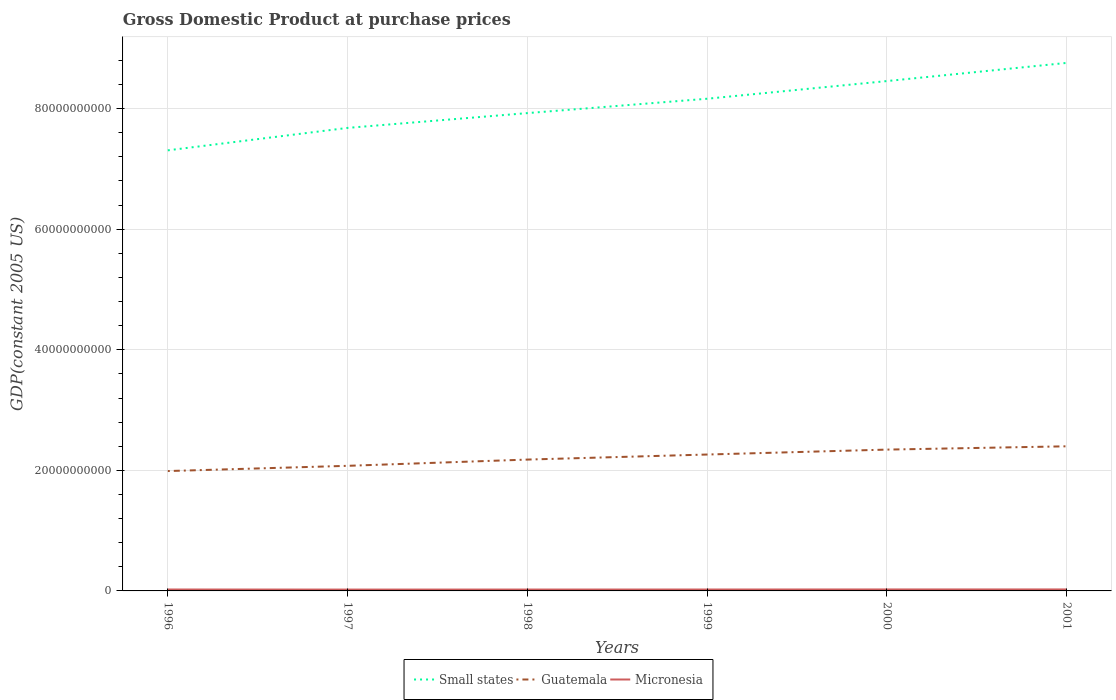Is the number of lines equal to the number of legend labels?
Give a very brief answer. Yes. Across all years, what is the maximum GDP at purchase prices in Small states?
Ensure brevity in your answer.  7.31e+1. In which year was the GDP at purchase prices in Micronesia maximum?
Ensure brevity in your answer.  1997. What is the total GDP at purchase prices in Micronesia in the graph?
Provide a short and direct response. -2.46e+07. What is the difference between the highest and the second highest GDP at purchase prices in Micronesia?
Make the answer very short. 2.46e+07. How many lines are there?
Your answer should be very brief. 3. Are the values on the major ticks of Y-axis written in scientific E-notation?
Make the answer very short. No. Where does the legend appear in the graph?
Ensure brevity in your answer.  Bottom center. What is the title of the graph?
Your answer should be compact. Gross Domestic Product at purchase prices. What is the label or title of the X-axis?
Ensure brevity in your answer.  Years. What is the label or title of the Y-axis?
Give a very brief answer. GDP(constant 2005 US). What is the GDP(constant 2005 US) in Small states in 1996?
Your response must be concise. 7.31e+1. What is the GDP(constant 2005 US) in Guatemala in 1996?
Your answer should be compact. 1.99e+1. What is the GDP(constant 2005 US) of Micronesia in 1996?
Ensure brevity in your answer.  2.37e+08. What is the GDP(constant 2005 US) of Small states in 1997?
Make the answer very short. 7.68e+1. What is the GDP(constant 2005 US) in Guatemala in 1997?
Ensure brevity in your answer.  2.08e+1. What is the GDP(constant 2005 US) of Micronesia in 1997?
Ensure brevity in your answer.  2.22e+08. What is the GDP(constant 2005 US) of Small states in 1998?
Your response must be concise. 7.93e+1. What is the GDP(constant 2005 US) in Guatemala in 1998?
Provide a succinct answer. 2.18e+1. What is the GDP(constant 2005 US) in Micronesia in 1998?
Ensure brevity in your answer.  2.29e+08. What is the GDP(constant 2005 US) of Small states in 1999?
Your response must be concise. 8.16e+1. What is the GDP(constant 2005 US) of Guatemala in 1999?
Give a very brief answer. 2.26e+1. What is the GDP(constant 2005 US) of Micronesia in 1999?
Provide a short and direct response. 2.32e+08. What is the GDP(constant 2005 US) in Small states in 2000?
Your answer should be very brief. 8.46e+1. What is the GDP(constant 2005 US) of Guatemala in 2000?
Provide a short and direct response. 2.34e+1. What is the GDP(constant 2005 US) in Micronesia in 2000?
Provide a succinct answer. 2.42e+08. What is the GDP(constant 2005 US) of Small states in 2001?
Give a very brief answer. 8.76e+1. What is the GDP(constant 2005 US) of Guatemala in 2001?
Provide a succinct answer. 2.40e+1. What is the GDP(constant 2005 US) of Micronesia in 2001?
Offer a terse response. 2.47e+08. Across all years, what is the maximum GDP(constant 2005 US) in Small states?
Provide a short and direct response. 8.76e+1. Across all years, what is the maximum GDP(constant 2005 US) in Guatemala?
Give a very brief answer. 2.40e+1. Across all years, what is the maximum GDP(constant 2005 US) in Micronesia?
Your answer should be very brief. 2.47e+08. Across all years, what is the minimum GDP(constant 2005 US) in Small states?
Provide a short and direct response. 7.31e+1. Across all years, what is the minimum GDP(constant 2005 US) in Guatemala?
Provide a short and direct response. 1.99e+1. Across all years, what is the minimum GDP(constant 2005 US) of Micronesia?
Offer a terse response. 2.22e+08. What is the total GDP(constant 2005 US) in Small states in the graph?
Give a very brief answer. 4.83e+11. What is the total GDP(constant 2005 US) in Guatemala in the graph?
Offer a very short reply. 1.32e+11. What is the total GDP(constant 2005 US) in Micronesia in the graph?
Provide a succinct answer. 1.41e+09. What is the difference between the GDP(constant 2005 US) of Small states in 1996 and that in 1997?
Keep it short and to the point. -3.72e+09. What is the difference between the GDP(constant 2005 US) in Guatemala in 1996 and that in 1997?
Offer a terse response. -8.68e+08. What is the difference between the GDP(constant 2005 US) in Micronesia in 1996 and that in 1997?
Your answer should be compact. 1.43e+07. What is the difference between the GDP(constant 2005 US) of Small states in 1996 and that in 1998?
Your answer should be compact. -6.17e+09. What is the difference between the GDP(constant 2005 US) in Guatemala in 1996 and that in 1998?
Your response must be concise. -1.90e+09. What is the difference between the GDP(constant 2005 US) of Micronesia in 1996 and that in 1998?
Keep it short and to the point. 7.78e+06. What is the difference between the GDP(constant 2005 US) in Small states in 1996 and that in 1999?
Offer a very short reply. -8.56e+09. What is the difference between the GDP(constant 2005 US) in Guatemala in 1996 and that in 1999?
Make the answer very short. -2.74e+09. What is the difference between the GDP(constant 2005 US) in Micronesia in 1996 and that in 1999?
Provide a succinct answer. 4.61e+06. What is the difference between the GDP(constant 2005 US) in Small states in 1996 and that in 2000?
Ensure brevity in your answer.  -1.15e+1. What is the difference between the GDP(constant 2005 US) in Guatemala in 1996 and that in 2000?
Give a very brief answer. -3.56e+09. What is the difference between the GDP(constant 2005 US) of Micronesia in 1996 and that in 2000?
Provide a succinct answer. -5.97e+06. What is the difference between the GDP(constant 2005 US) in Small states in 1996 and that in 2001?
Offer a terse response. -1.45e+1. What is the difference between the GDP(constant 2005 US) in Guatemala in 1996 and that in 2001?
Your response must be concise. -4.11e+09. What is the difference between the GDP(constant 2005 US) in Micronesia in 1996 and that in 2001?
Offer a terse response. -1.02e+07. What is the difference between the GDP(constant 2005 US) in Small states in 1997 and that in 1998?
Your response must be concise. -2.45e+09. What is the difference between the GDP(constant 2005 US) in Guatemala in 1997 and that in 1998?
Your response must be concise. -1.04e+09. What is the difference between the GDP(constant 2005 US) of Micronesia in 1997 and that in 1998?
Offer a terse response. -6.57e+06. What is the difference between the GDP(constant 2005 US) of Small states in 1997 and that in 1999?
Your response must be concise. -4.84e+09. What is the difference between the GDP(constant 2005 US) of Guatemala in 1997 and that in 1999?
Provide a short and direct response. -1.87e+09. What is the difference between the GDP(constant 2005 US) in Micronesia in 1997 and that in 1999?
Provide a succinct answer. -9.73e+06. What is the difference between the GDP(constant 2005 US) in Small states in 1997 and that in 2000?
Keep it short and to the point. -7.77e+09. What is the difference between the GDP(constant 2005 US) in Guatemala in 1997 and that in 2000?
Offer a terse response. -2.69e+09. What is the difference between the GDP(constant 2005 US) of Micronesia in 1997 and that in 2000?
Keep it short and to the point. -2.03e+07. What is the difference between the GDP(constant 2005 US) of Small states in 1997 and that in 2001?
Keep it short and to the point. -1.08e+1. What is the difference between the GDP(constant 2005 US) of Guatemala in 1997 and that in 2001?
Your answer should be very brief. -3.24e+09. What is the difference between the GDP(constant 2005 US) in Micronesia in 1997 and that in 2001?
Your answer should be very brief. -2.46e+07. What is the difference between the GDP(constant 2005 US) in Small states in 1998 and that in 1999?
Your answer should be very brief. -2.38e+09. What is the difference between the GDP(constant 2005 US) of Guatemala in 1998 and that in 1999?
Give a very brief answer. -8.38e+08. What is the difference between the GDP(constant 2005 US) of Micronesia in 1998 and that in 1999?
Make the answer very short. -3.17e+06. What is the difference between the GDP(constant 2005 US) in Small states in 1998 and that in 2000?
Provide a short and direct response. -5.32e+09. What is the difference between the GDP(constant 2005 US) in Guatemala in 1998 and that in 2000?
Offer a terse response. -1.65e+09. What is the difference between the GDP(constant 2005 US) in Micronesia in 1998 and that in 2000?
Provide a succinct answer. -1.37e+07. What is the difference between the GDP(constant 2005 US) of Small states in 1998 and that in 2001?
Offer a terse response. -8.33e+09. What is the difference between the GDP(constant 2005 US) of Guatemala in 1998 and that in 2001?
Your answer should be compact. -2.20e+09. What is the difference between the GDP(constant 2005 US) of Micronesia in 1998 and that in 2001?
Your response must be concise. -1.80e+07. What is the difference between the GDP(constant 2005 US) in Small states in 1999 and that in 2000?
Keep it short and to the point. -2.93e+09. What is the difference between the GDP(constant 2005 US) of Guatemala in 1999 and that in 2000?
Offer a very short reply. -8.17e+08. What is the difference between the GDP(constant 2005 US) in Micronesia in 1999 and that in 2000?
Offer a very short reply. -1.06e+07. What is the difference between the GDP(constant 2005 US) in Small states in 1999 and that in 2001?
Your response must be concise. -5.94e+09. What is the difference between the GDP(constant 2005 US) in Guatemala in 1999 and that in 2001?
Offer a terse response. -1.36e+09. What is the difference between the GDP(constant 2005 US) in Micronesia in 1999 and that in 2001?
Give a very brief answer. -1.48e+07. What is the difference between the GDP(constant 2005 US) in Small states in 2000 and that in 2001?
Keep it short and to the point. -3.01e+09. What is the difference between the GDP(constant 2005 US) of Guatemala in 2000 and that in 2001?
Provide a succinct answer. -5.47e+08. What is the difference between the GDP(constant 2005 US) of Micronesia in 2000 and that in 2001?
Keep it short and to the point. -4.24e+06. What is the difference between the GDP(constant 2005 US) of Small states in 1996 and the GDP(constant 2005 US) of Guatemala in 1997?
Make the answer very short. 5.23e+1. What is the difference between the GDP(constant 2005 US) in Small states in 1996 and the GDP(constant 2005 US) in Micronesia in 1997?
Make the answer very short. 7.29e+1. What is the difference between the GDP(constant 2005 US) of Guatemala in 1996 and the GDP(constant 2005 US) of Micronesia in 1997?
Offer a terse response. 1.97e+1. What is the difference between the GDP(constant 2005 US) in Small states in 1996 and the GDP(constant 2005 US) in Guatemala in 1998?
Ensure brevity in your answer.  5.13e+1. What is the difference between the GDP(constant 2005 US) in Small states in 1996 and the GDP(constant 2005 US) in Micronesia in 1998?
Offer a terse response. 7.29e+1. What is the difference between the GDP(constant 2005 US) in Guatemala in 1996 and the GDP(constant 2005 US) in Micronesia in 1998?
Offer a terse response. 1.97e+1. What is the difference between the GDP(constant 2005 US) of Small states in 1996 and the GDP(constant 2005 US) of Guatemala in 1999?
Keep it short and to the point. 5.05e+1. What is the difference between the GDP(constant 2005 US) of Small states in 1996 and the GDP(constant 2005 US) of Micronesia in 1999?
Your response must be concise. 7.29e+1. What is the difference between the GDP(constant 2005 US) of Guatemala in 1996 and the GDP(constant 2005 US) of Micronesia in 1999?
Keep it short and to the point. 1.97e+1. What is the difference between the GDP(constant 2005 US) of Small states in 1996 and the GDP(constant 2005 US) of Guatemala in 2000?
Give a very brief answer. 4.96e+1. What is the difference between the GDP(constant 2005 US) in Small states in 1996 and the GDP(constant 2005 US) in Micronesia in 2000?
Offer a very short reply. 7.28e+1. What is the difference between the GDP(constant 2005 US) of Guatemala in 1996 and the GDP(constant 2005 US) of Micronesia in 2000?
Your answer should be very brief. 1.96e+1. What is the difference between the GDP(constant 2005 US) of Small states in 1996 and the GDP(constant 2005 US) of Guatemala in 2001?
Provide a succinct answer. 4.91e+1. What is the difference between the GDP(constant 2005 US) of Small states in 1996 and the GDP(constant 2005 US) of Micronesia in 2001?
Your response must be concise. 7.28e+1. What is the difference between the GDP(constant 2005 US) in Guatemala in 1996 and the GDP(constant 2005 US) in Micronesia in 2001?
Offer a terse response. 1.96e+1. What is the difference between the GDP(constant 2005 US) of Small states in 1997 and the GDP(constant 2005 US) of Guatemala in 1998?
Offer a terse response. 5.50e+1. What is the difference between the GDP(constant 2005 US) of Small states in 1997 and the GDP(constant 2005 US) of Micronesia in 1998?
Provide a short and direct response. 7.66e+1. What is the difference between the GDP(constant 2005 US) in Guatemala in 1997 and the GDP(constant 2005 US) in Micronesia in 1998?
Offer a terse response. 2.05e+1. What is the difference between the GDP(constant 2005 US) of Small states in 1997 and the GDP(constant 2005 US) of Guatemala in 1999?
Your answer should be compact. 5.42e+1. What is the difference between the GDP(constant 2005 US) in Small states in 1997 and the GDP(constant 2005 US) in Micronesia in 1999?
Your response must be concise. 7.66e+1. What is the difference between the GDP(constant 2005 US) of Guatemala in 1997 and the GDP(constant 2005 US) of Micronesia in 1999?
Your answer should be compact. 2.05e+1. What is the difference between the GDP(constant 2005 US) of Small states in 1997 and the GDP(constant 2005 US) of Guatemala in 2000?
Provide a succinct answer. 5.34e+1. What is the difference between the GDP(constant 2005 US) in Small states in 1997 and the GDP(constant 2005 US) in Micronesia in 2000?
Provide a short and direct response. 7.66e+1. What is the difference between the GDP(constant 2005 US) in Guatemala in 1997 and the GDP(constant 2005 US) in Micronesia in 2000?
Your response must be concise. 2.05e+1. What is the difference between the GDP(constant 2005 US) of Small states in 1997 and the GDP(constant 2005 US) of Guatemala in 2001?
Ensure brevity in your answer.  5.28e+1. What is the difference between the GDP(constant 2005 US) in Small states in 1997 and the GDP(constant 2005 US) in Micronesia in 2001?
Provide a short and direct response. 7.66e+1. What is the difference between the GDP(constant 2005 US) in Guatemala in 1997 and the GDP(constant 2005 US) in Micronesia in 2001?
Your response must be concise. 2.05e+1. What is the difference between the GDP(constant 2005 US) in Small states in 1998 and the GDP(constant 2005 US) in Guatemala in 1999?
Offer a terse response. 5.66e+1. What is the difference between the GDP(constant 2005 US) in Small states in 1998 and the GDP(constant 2005 US) in Micronesia in 1999?
Ensure brevity in your answer.  7.90e+1. What is the difference between the GDP(constant 2005 US) of Guatemala in 1998 and the GDP(constant 2005 US) of Micronesia in 1999?
Offer a very short reply. 2.16e+1. What is the difference between the GDP(constant 2005 US) of Small states in 1998 and the GDP(constant 2005 US) of Guatemala in 2000?
Your response must be concise. 5.58e+1. What is the difference between the GDP(constant 2005 US) of Small states in 1998 and the GDP(constant 2005 US) of Micronesia in 2000?
Provide a succinct answer. 7.90e+1. What is the difference between the GDP(constant 2005 US) of Guatemala in 1998 and the GDP(constant 2005 US) of Micronesia in 2000?
Make the answer very short. 2.15e+1. What is the difference between the GDP(constant 2005 US) of Small states in 1998 and the GDP(constant 2005 US) of Guatemala in 2001?
Your answer should be compact. 5.53e+1. What is the difference between the GDP(constant 2005 US) in Small states in 1998 and the GDP(constant 2005 US) in Micronesia in 2001?
Provide a succinct answer. 7.90e+1. What is the difference between the GDP(constant 2005 US) in Guatemala in 1998 and the GDP(constant 2005 US) in Micronesia in 2001?
Keep it short and to the point. 2.15e+1. What is the difference between the GDP(constant 2005 US) in Small states in 1999 and the GDP(constant 2005 US) in Guatemala in 2000?
Ensure brevity in your answer.  5.82e+1. What is the difference between the GDP(constant 2005 US) in Small states in 1999 and the GDP(constant 2005 US) in Micronesia in 2000?
Your answer should be compact. 8.14e+1. What is the difference between the GDP(constant 2005 US) of Guatemala in 1999 and the GDP(constant 2005 US) of Micronesia in 2000?
Ensure brevity in your answer.  2.24e+1. What is the difference between the GDP(constant 2005 US) of Small states in 1999 and the GDP(constant 2005 US) of Guatemala in 2001?
Offer a terse response. 5.77e+1. What is the difference between the GDP(constant 2005 US) in Small states in 1999 and the GDP(constant 2005 US) in Micronesia in 2001?
Your response must be concise. 8.14e+1. What is the difference between the GDP(constant 2005 US) of Guatemala in 1999 and the GDP(constant 2005 US) of Micronesia in 2001?
Your response must be concise. 2.24e+1. What is the difference between the GDP(constant 2005 US) in Small states in 2000 and the GDP(constant 2005 US) in Guatemala in 2001?
Provide a succinct answer. 6.06e+1. What is the difference between the GDP(constant 2005 US) in Small states in 2000 and the GDP(constant 2005 US) in Micronesia in 2001?
Provide a succinct answer. 8.43e+1. What is the difference between the GDP(constant 2005 US) in Guatemala in 2000 and the GDP(constant 2005 US) in Micronesia in 2001?
Make the answer very short. 2.32e+1. What is the average GDP(constant 2005 US) of Small states per year?
Your answer should be compact. 8.05e+1. What is the average GDP(constant 2005 US) in Guatemala per year?
Offer a very short reply. 2.21e+1. What is the average GDP(constant 2005 US) of Micronesia per year?
Provide a short and direct response. 2.35e+08. In the year 1996, what is the difference between the GDP(constant 2005 US) in Small states and GDP(constant 2005 US) in Guatemala?
Your response must be concise. 5.32e+1. In the year 1996, what is the difference between the GDP(constant 2005 US) of Small states and GDP(constant 2005 US) of Micronesia?
Keep it short and to the point. 7.28e+1. In the year 1996, what is the difference between the GDP(constant 2005 US) in Guatemala and GDP(constant 2005 US) in Micronesia?
Keep it short and to the point. 1.96e+1. In the year 1997, what is the difference between the GDP(constant 2005 US) of Small states and GDP(constant 2005 US) of Guatemala?
Make the answer very short. 5.61e+1. In the year 1997, what is the difference between the GDP(constant 2005 US) in Small states and GDP(constant 2005 US) in Micronesia?
Your response must be concise. 7.66e+1. In the year 1997, what is the difference between the GDP(constant 2005 US) of Guatemala and GDP(constant 2005 US) of Micronesia?
Provide a succinct answer. 2.05e+1. In the year 1998, what is the difference between the GDP(constant 2005 US) of Small states and GDP(constant 2005 US) of Guatemala?
Ensure brevity in your answer.  5.75e+1. In the year 1998, what is the difference between the GDP(constant 2005 US) in Small states and GDP(constant 2005 US) in Micronesia?
Provide a short and direct response. 7.90e+1. In the year 1998, what is the difference between the GDP(constant 2005 US) in Guatemala and GDP(constant 2005 US) in Micronesia?
Offer a terse response. 2.16e+1. In the year 1999, what is the difference between the GDP(constant 2005 US) in Small states and GDP(constant 2005 US) in Guatemala?
Offer a very short reply. 5.90e+1. In the year 1999, what is the difference between the GDP(constant 2005 US) of Small states and GDP(constant 2005 US) of Micronesia?
Offer a very short reply. 8.14e+1. In the year 1999, what is the difference between the GDP(constant 2005 US) of Guatemala and GDP(constant 2005 US) of Micronesia?
Your answer should be compact. 2.24e+1. In the year 2000, what is the difference between the GDP(constant 2005 US) of Small states and GDP(constant 2005 US) of Guatemala?
Your answer should be compact. 6.11e+1. In the year 2000, what is the difference between the GDP(constant 2005 US) of Small states and GDP(constant 2005 US) of Micronesia?
Provide a succinct answer. 8.43e+1. In the year 2000, what is the difference between the GDP(constant 2005 US) in Guatemala and GDP(constant 2005 US) in Micronesia?
Provide a succinct answer. 2.32e+1. In the year 2001, what is the difference between the GDP(constant 2005 US) of Small states and GDP(constant 2005 US) of Guatemala?
Provide a short and direct response. 6.36e+1. In the year 2001, what is the difference between the GDP(constant 2005 US) in Small states and GDP(constant 2005 US) in Micronesia?
Offer a very short reply. 8.73e+1. In the year 2001, what is the difference between the GDP(constant 2005 US) of Guatemala and GDP(constant 2005 US) of Micronesia?
Keep it short and to the point. 2.37e+1. What is the ratio of the GDP(constant 2005 US) of Small states in 1996 to that in 1997?
Your response must be concise. 0.95. What is the ratio of the GDP(constant 2005 US) of Guatemala in 1996 to that in 1997?
Provide a short and direct response. 0.96. What is the ratio of the GDP(constant 2005 US) in Micronesia in 1996 to that in 1997?
Provide a succinct answer. 1.06. What is the ratio of the GDP(constant 2005 US) of Small states in 1996 to that in 1998?
Your answer should be very brief. 0.92. What is the ratio of the GDP(constant 2005 US) of Guatemala in 1996 to that in 1998?
Give a very brief answer. 0.91. What is the ratio of the GDP(constant 2005 US) of Micronesia in 1996 to that in 1998?
Offer a very short reply. 1.03. What is the ratio of the GDP(constant 2005 US) in Small states in 1996 to that in 1999?
Ensure brevity in your answer.  0.9. What is the ratio of the GDP(constant 2005 US) in Guatemala in 1996 to that in 1999?
Your answer should be very brief. 0.88. What is the ratio of the GDP(constant 2005 US) of Micronesia in 1996 to that in 1999?
Ensure brevity in your answer.  1.02. What is the ratio of the GDP(constant 2005 US) in Small states in 1996 to that in 2000?
Offer a terse response. 0.86. What is the ratio of the GDP(constant 2005 US) in Guatemala in 1996 to that in 2000?
Your response must be concise. 0.85. What is the ratio of the GDP(constant 2005 US) in Micronesia in 1996 to that in 2000?
Offer a very short reply. 0.98. What is the ratio of the GDP(constant 2005 US) of Small states in 1996 to that in 2001?
Provide a short and direct response. 0.83. What is the ratio of the GDP(constant 2005 US) of Guatemala in 1996 to that in 2001?
Keep it short and to the point. 0.83. What is the ratio of the GDP(constant 2005 US) of Micronesia in 1996 to that in 2001?
Offer a very short reply. 0.96. What is the ratio of the GDP(constant 2005 US) in Small states in 1997 to that in 1998?
Offer a very short reply. 0.97. What is the ratio of the GDP(constant 2005 US) in Guatemala in 1997 to that in 1998?
Ensure brevity in your answer.  0.95. What is the ratio of the GDP(constant 2005 US) in Micronesia in 1997 to that in 1998?
Keep it short and to the point. 0.97. What is the ratio of the GDP(constant 2005 US) in Small states in 1997 to that in 1999?
Your answer should be very brief. 0.94. What is the ratio of the GDP(constant 2005 US) in Guatemala in 1997 to that in 1999?
Your response must be concise. 0.92. What is the ratio of the GDP(constant 2005 US) of Micronesia in 1997 to that in 1999?
Your answer should be very brief. 0.96. What is the ratio of the GDP(constant 2005 US) of Small states in 1997 to that in 2000?
Your answer should be very brief. 0.91. What is the ratio of the GDP(constant 2005 US) in Guatemala in 1997 to that in 2000?
Your answer should be very brief. 0.89. What is the ratio of the GDP(constant 2005 US) of Micronesia in 1997 to that in 2000?
Your answer should be compact. 0.92. What is the ratio of the GDP(constant 2005 US) of Small states in 1997 to that in 2001?
Offer a terse response. 0.88. What is the ratio of the GDP(constant 2005 US) of Guatemala in 1997 to that in 2001?
Offer a very short reply. 0.86. What is the ratio of the GDP(constant 2005 US) in Micronesia in 1997 to that in 2001?
Give a very brief answer. 0.9. What is the ratio of the GDP(constant 2005 US) in Small states in 1998 to that in 1999?
Keep it short and to the point. 0.97. What is the ratio of the GDP(constant 2005 US) of Micronesia in 1998 to that in 1999?
Offer a very short reply. 0.99. What is the ratio of the GDP(constant 2005 US) of Small states in 1998 to that in 2000?
Provide a succinct answer. 0.94. What is the ratio of the GDP(constant 2005 US) of Guatemala in 1998 to that in 2000?
Offer a terse response. 0.93. What is the ratio of the GDP(constant 2005 US) of Micronesia in 1998 to that in 2000?
Your answer should be compact. 0.94. What is the ratio of the GDP(constant 2005 US) of Small states in 1998 to that in 2001?
Make the answer very short. 0.9. What is the ratio of the GDP(constant 2005 US) of Guatemala in 1998 to that in 2001?
Make the answer very short. 0.91. What is the ratio of the GDP(constant 2005 US) of Micronesia in 1998 to that in 2001?
Keep it short and to the point. 0.93. What is the ratio of the GDP(constant 2005 US) of Small states in 1999 to that in 2000?
Give a very brief answer. 0.97. What is the ratio of the GDP(constant 2005 US) of Guatemala in 1999 to that in 2000?
Provide a succinct answer. 0.97. What is the ratio of the GDP(constant 2005 US) in Micronesia in 1999 to that in 2000?
Provide a short and direct response. 0.96. What is the ratio of the GDP(constant 2005 US) of Small states in 1999 to that in 2001?
Make the answer very short. 0.93. What is the ratio of the GDP(constant 2005 US) of Guatemala in 1999 to that in 2001?
Your answer should be compact. 0.94. What is the ratio of the GDP(constant 2005 US) in Micronesia in 1999 to that in 2001?
Ensure brevity in your answer.  0.94. What is the ratio of the GDP(constant 2005 US) in Small states in 2000 to that in 2001?
Give a very brief answer. 0.97. What is the ratio of the GDP(constant 2005 US) in Guatemala in 2000 to that in 2001?
Make the answer very short. 0.98. What is the ratio of the GDP(constant 2005 US) in Micronesia in 2000 to that in 2001?
Offer a very short reply. 0.98. What is the difference between the highest and the second highest GDP(constant 2005 US) in Small states?
Provide a short and direct response. 3.01e+09. What is the difference between the highest and the second highest GDP(constant 2005 US) of Guatemala?
Ensure brevity in your answer.  5.47e+08. What is the difference between the highest and the second highest GDP(constant 2005 US) of Micronesia?
Your response must be concise. 4.24e+06. What is the difference between the highest and the lowest GDP(constant 2005 US) in Small states?
Your answer should be compact. 1.45e+1. What is the difference between the highest and the lowest GDP(constant 2005 US) of Guatemala?
Provide a succinct answer. 4.11e+09. What is the difference between the highest and the lowest GDP(constant 2005 US) of Micronesia?
Your answer should be compact. 2.46e+07. 